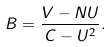<formula> <loc_0><loc_0><loc_500><loc_500>B = \frac { V - N U } { C - U ^ { 2 } } .</formula> 